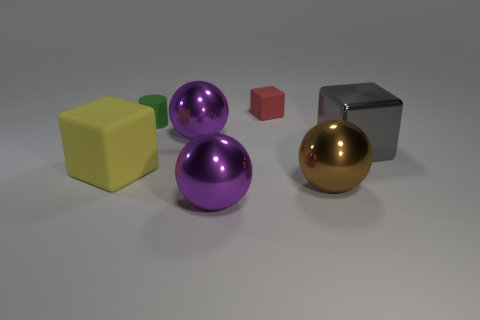Subtract all red spheres. Subtract all purple blocks. How many spheres are left? 3 Add 2 large purple balls. How many objects exist? 9 Subtract all blocks. How many objects are left? 4 Add 5 yellow blocks. How many yellow blocks are left? 6 Add 2 large purple rubber spheres. How many large purple rubber spheres exist? 2 Subtract 0 cyan spheres. How many objects are left? 7 Subtract all big gray metallic cylinders. Subtract all red matte cubes. How many objects are left? 6 